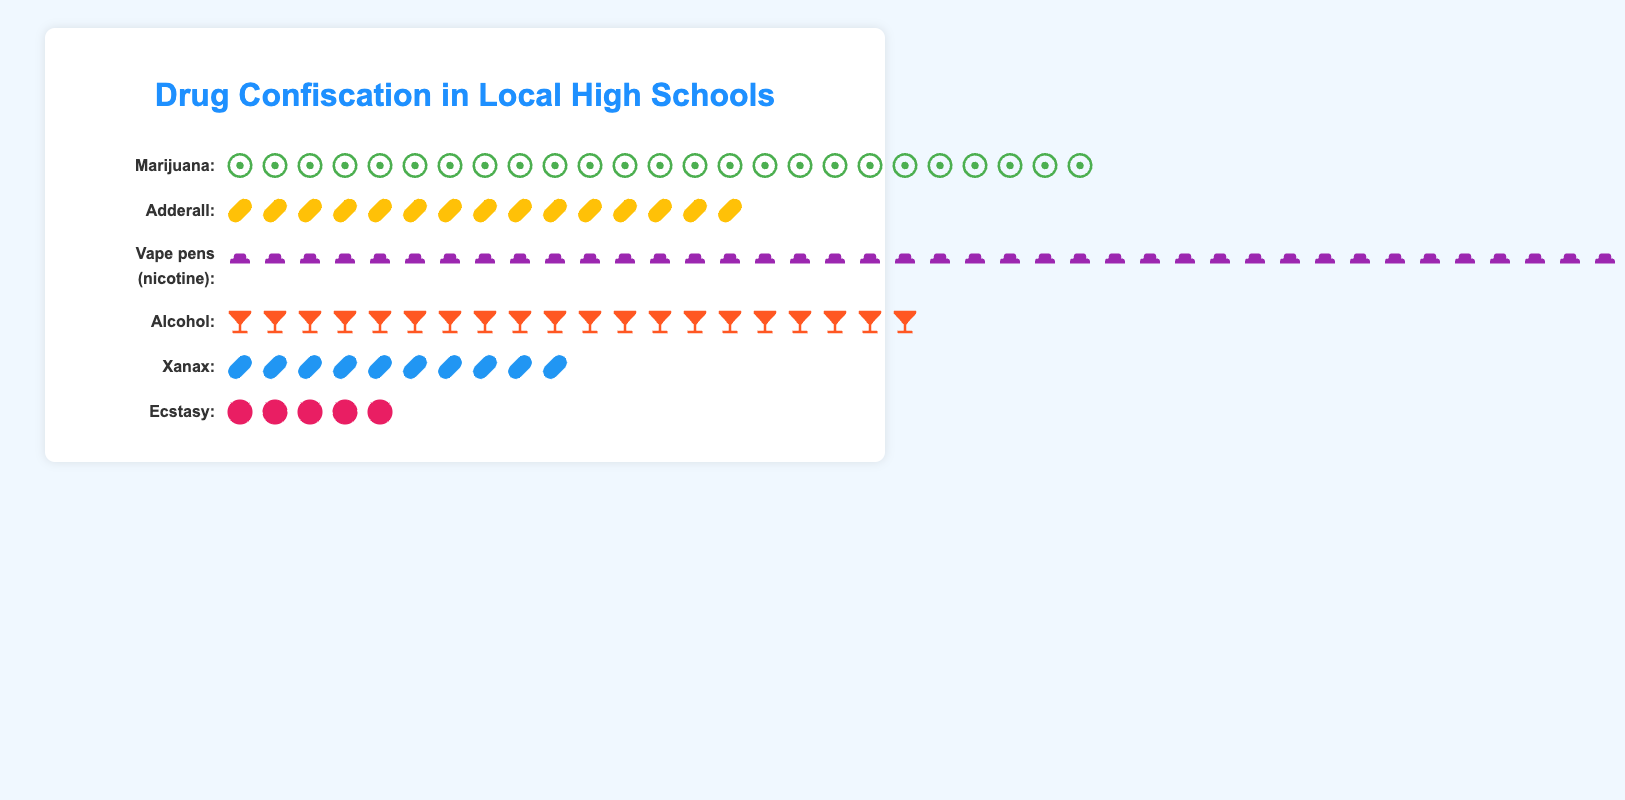Which drug substance was confiscated the most frequently? The most frequently confiscated substance is indicated by the longest row of icons, which represent the count of each drug. In this plot, the row for "Vape pens (nicotine)" has the most icons.
Answer: Vape pens (nicotine) How many more vape pens were confiscated compared to Xanax? Count the icons for "Vape pens (nicotine)" and "Xanax" and find the difference between the two. There are 40 vape pens and 10 Xanax, so the difference is 40 - 10.
Answer: 30 What is the total number of drugs confiscated? Sum up the counts of all the substances. The counts are: Marijuana (25), Adderall (15), Vape pens (40), Alcohol (20), Xanax (10), and Ecstasy (5). So, the total is 25 + 15 + 40 + 20 + 10 + 5.
Answer: 115 Which drugs have a confiscation count equal to or greater than 20? Examine each row and count the icons. The substances with 20 or more icons are "Marijuana" (25), "Vape pens (nicotine)" (40), and "Alcohol" (20).
Answer: Marijuana, Vape pens (nicotine), Alcohol How does the number of Adderall confiscated compare to the number of Ecstasy confiscated? Count the icons for "Adderall" and "Ecstasy" and compare them. Adderall has 15 icons while Ecstasy has 5 icons. 15 is greater than 5.
Answer: Adderall is greater than Ecstasy How many different types of drugs were confiscated? Count the number of distinct rows in the plot. Each row represents a different substance.
Answer: 6 Is the number of alcohol-related confiscations higher than that of Xanax? Count the icons in the rows for "Alcohol" and "Xanax." Alcohol has 20 icons and Xanax has 10. 20 is greater than 10.
Answer: Yes What is the average number of confiscations per drug type? Calculate the total number of confiscations (115) and divide by the number of drug types (6). 115 / 6 = approximately 19.17.
Answer: 19.17 Which substance had the least number of confiscations? Look for the row with the fewest icons. The row for "Ecstasy" has the fewest icons, with 5.
Answer: Ecstasy 